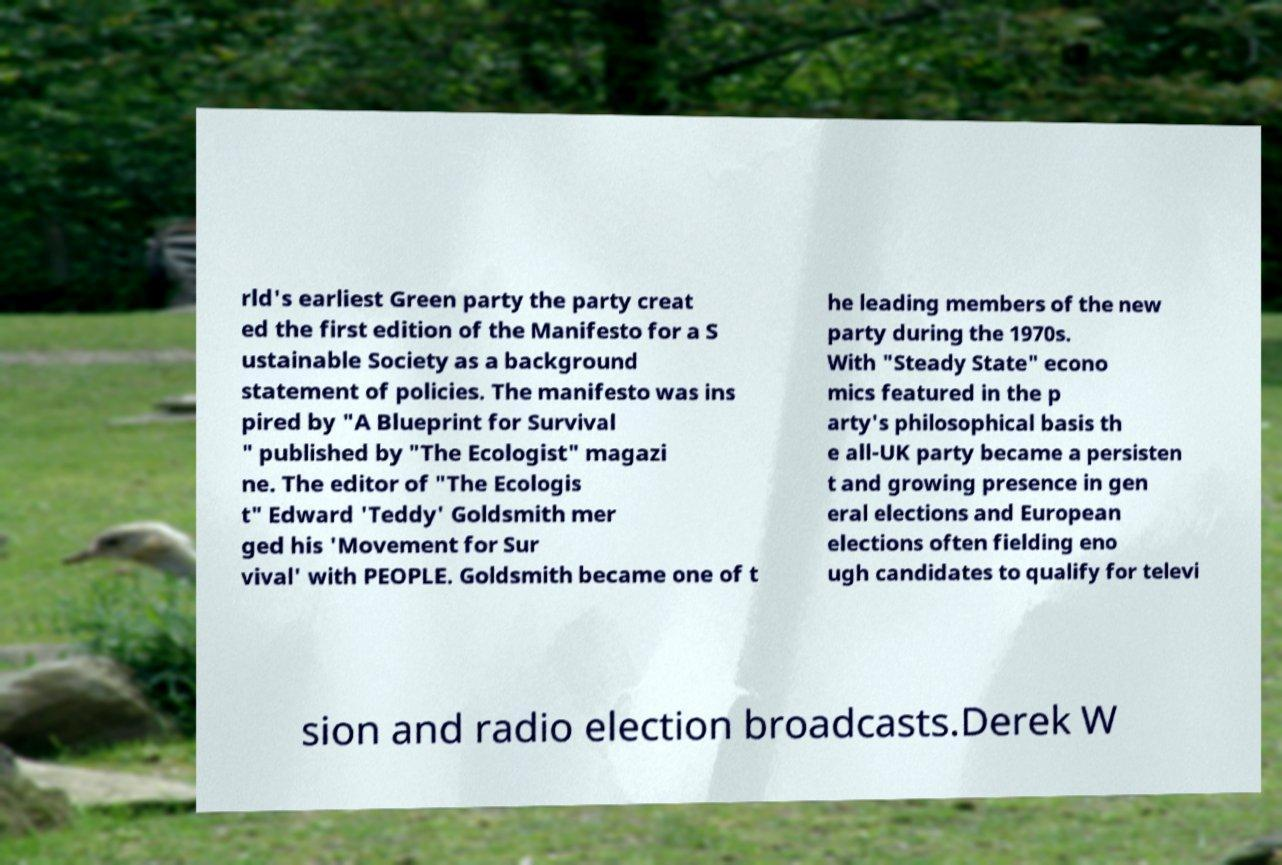Can you read and provide the text displayed in the image?This photo seems to have some interesting text. Can you extract and type it out for me? rld's earliest Green party the party creat ed the first edition of the Manifesto for a S ustainable Society as a background statement of policies. The manifesto was ins pired by "A Blueprint for Survival " published by "The Ecologist" magazi ne. The editor of "The Ecologis t" Edward 'Teddy' Goldsmith mer ged his 'Movement for Sur vival' with PEOPLE. Goldsmith became one of t he leading members of the new party during the 1970s. With "Steady State" econo mics featured in the p arty's philosophical basis th e all-UK party became a persisten t and growing presence in gen eral elections and European elections often fielding eno ugh candidates to qualify for televi sion and radio election broadcasts.Derek W 